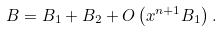<formula> <loc_0><loc_0><loc_500><loc_500>B = B _ { 1 } + B _ { 2 } + O \left ( x ^ { n + 1 } B _ { 1 } \right ) .</formula> 